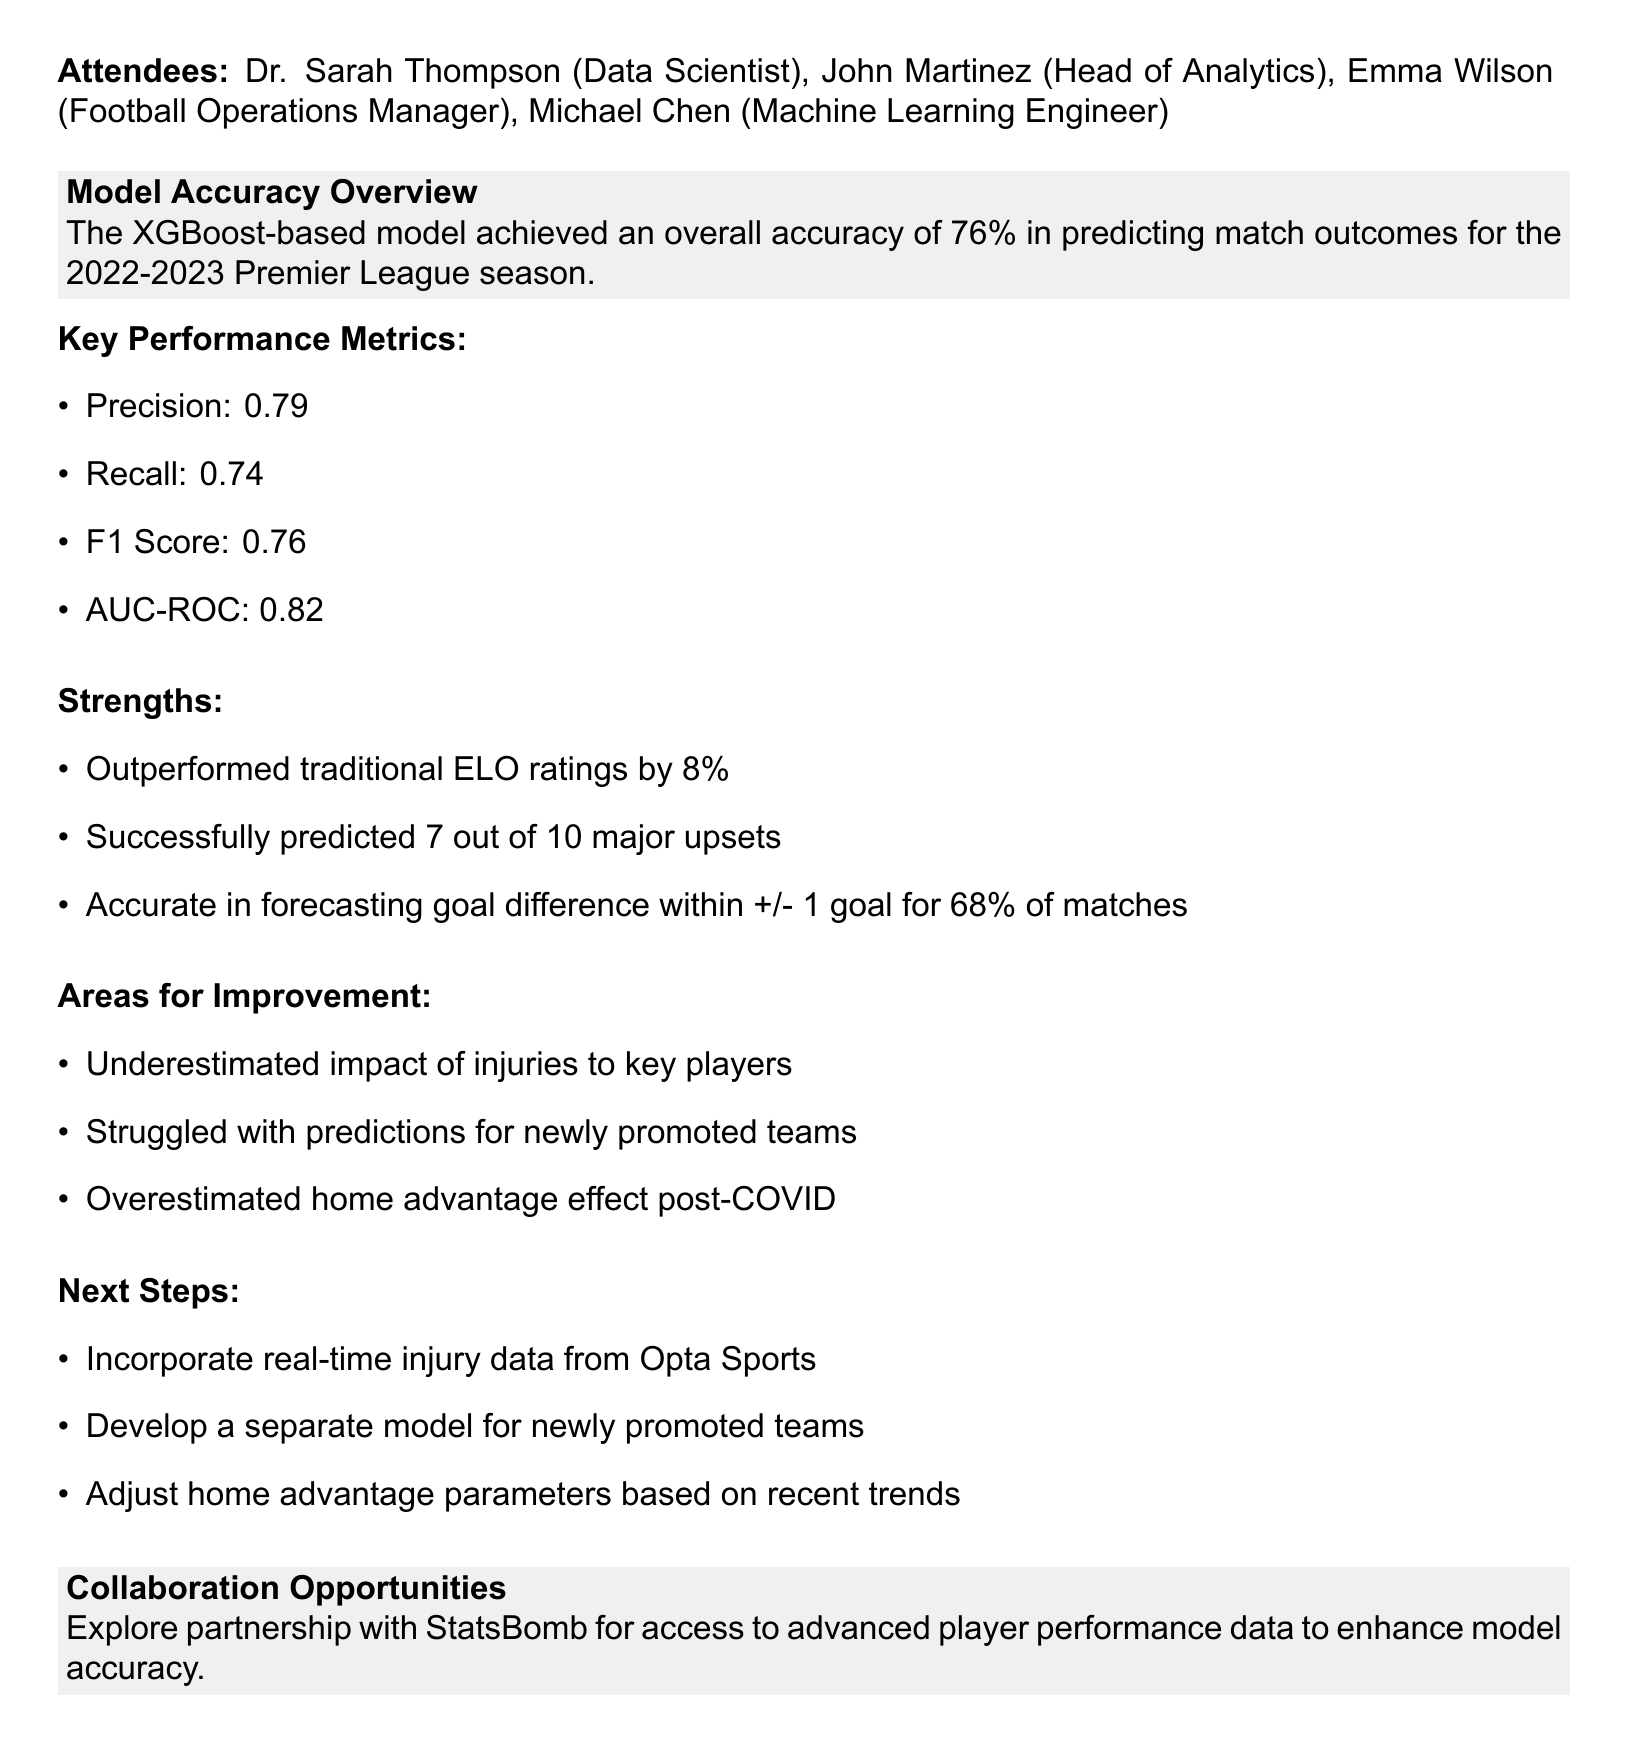what is the overall accuracy of the model? The overall accuracy of the model is stated in the document as 76%.
Answer: 76% who is the Head of Analytics? The document lists John Martinez as the Head of Analytics.
Answer: John Martinez what was the F1 Score achieved by the model? The F1 Score is provided in the details of key performance metrics as 0.76.
Answer: 0.76 how many major upsets did the model correctly predict? The document indicates that the model successfully predicted 7 out of 10 major upsets.
Answer: 7 what area for improvement relates to team performance? The document mentions that the model struggled with predictions for newly promoted teams as an area for improvement.
Answer: Newly promoted teams what is one of the next steps mentioned in the meeting? The document lists several next steps, one of which is to incorporate real-time injury data from Opta Sports.
Answer: Incorporate real-time injury data from Opta Sports which performance metric has the value of 0.79? The metric corresponding to the value of 0.79 is Precision according to the key performance metrics section of the document.
Answer: Precision what is a proposed collaboration mentioned in the document? The document discusses exploring a partnership with StatsBomb for access to advanced player performance data.
Answer: Partnership with StatsBomb 